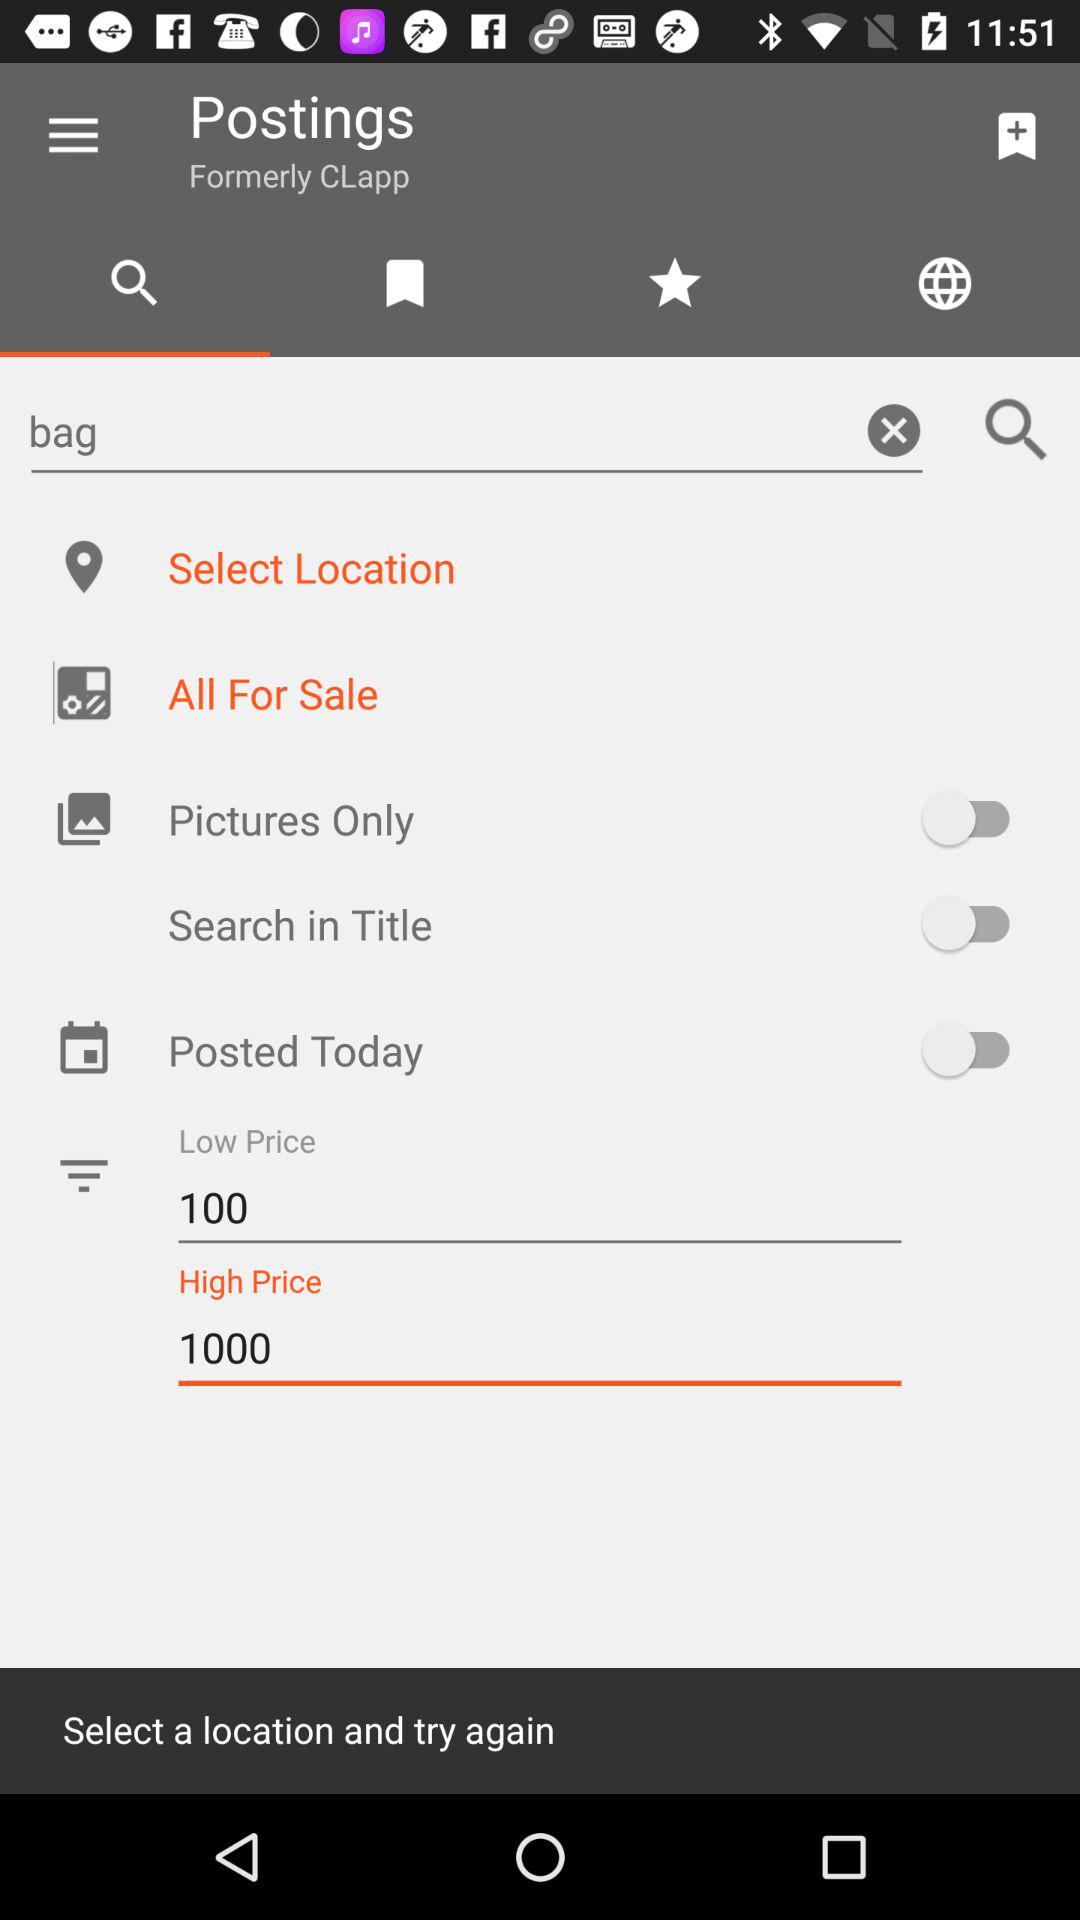What is the status of the "Pictures Only"? The status is "off". 